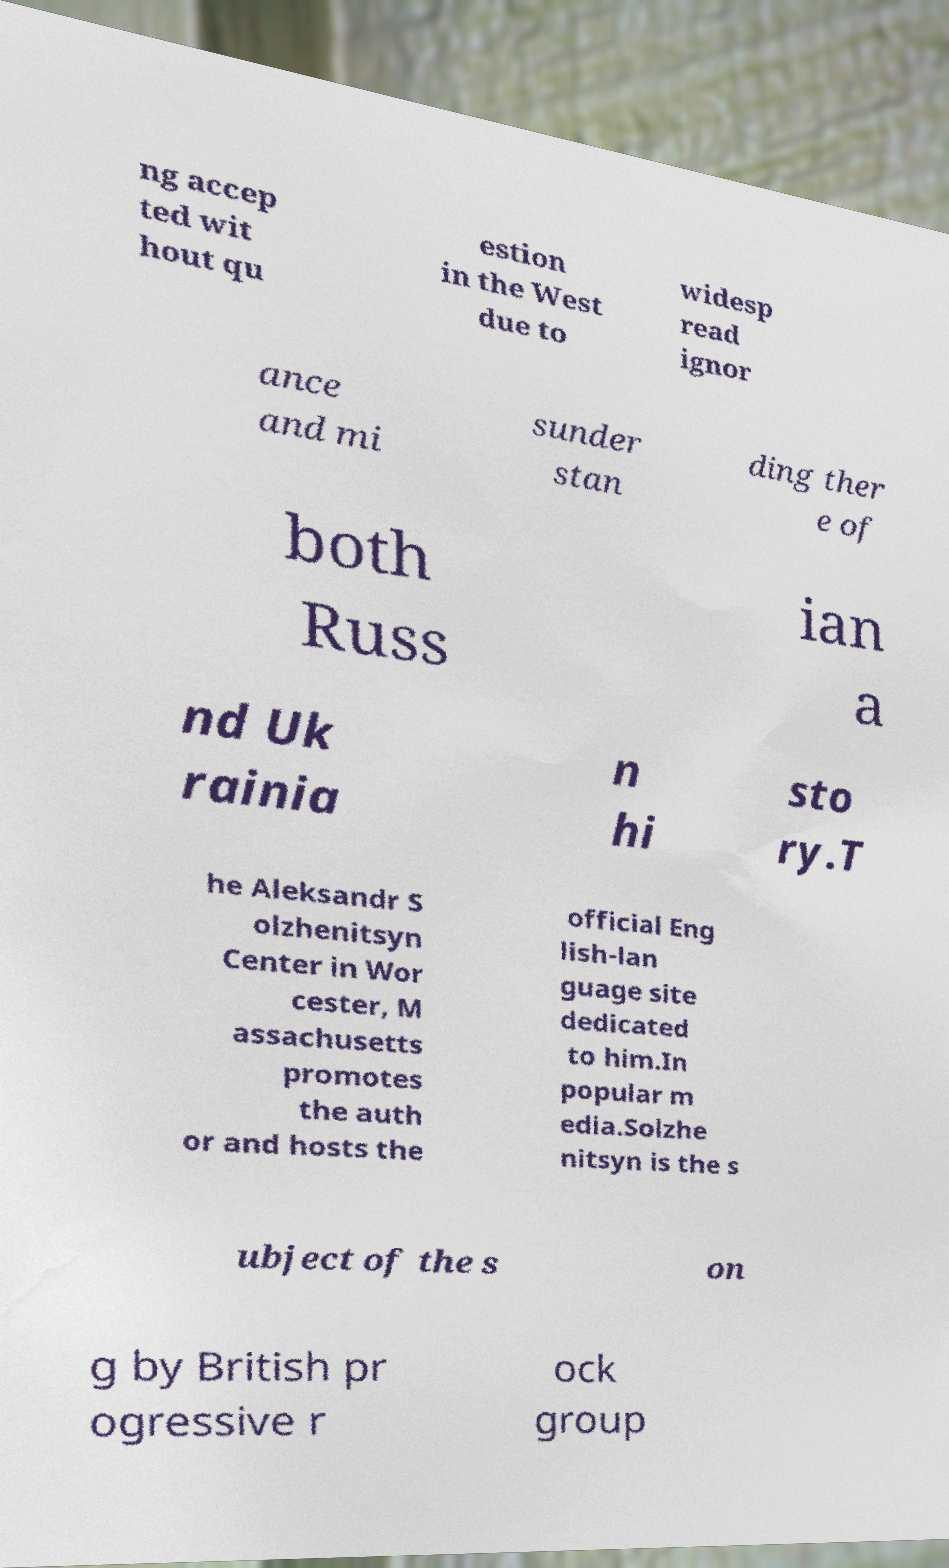Could you assist in decoding the text presented in this image and type it out clearly? ng accep ted wit hout qu estion in the West due to widesp read ignor ance and mi sunder stan ding ther e of both Russ ian a nd Uk rainia n hi sto ry.T he Aleksandr S olzhenitsyn Center in Wor cester, M assachusetts promotes the auth or and hosts the official Eng lish-lan guage site dedicated to him.In popular m edia.Solzhe nitsyn is the s ubject of the s on g by British pr ogressive r ock group 